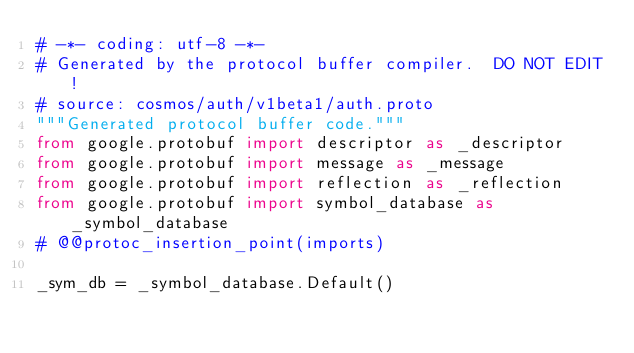<code> <loc_0><loc_0><loc_500><loc_500><_Python_># -*- coding: utf-8 -*-
# Generated by the protocol buffer compiler.  DO NOT EDIT!
# source: cosmos/auth/v1beta1/auth.proto
"""Generated protocol buffer code."""
from google.protobuf import descriptor as _descriptor
from google.protobuf import message as _message
from google.protobuf import reflection as _reflection
from google.protobuf import symbol_database as _symbol_database
# @@protoc_insertion_point(imports)

_sym_db = _symbol_database.Default()

</code> 